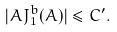<formula> <loc_0><loc_0><loc_500><loc_500>| A J ^ { b } _ { 1 } ( A ) | \leq C ^ { \prime } .</formula> 